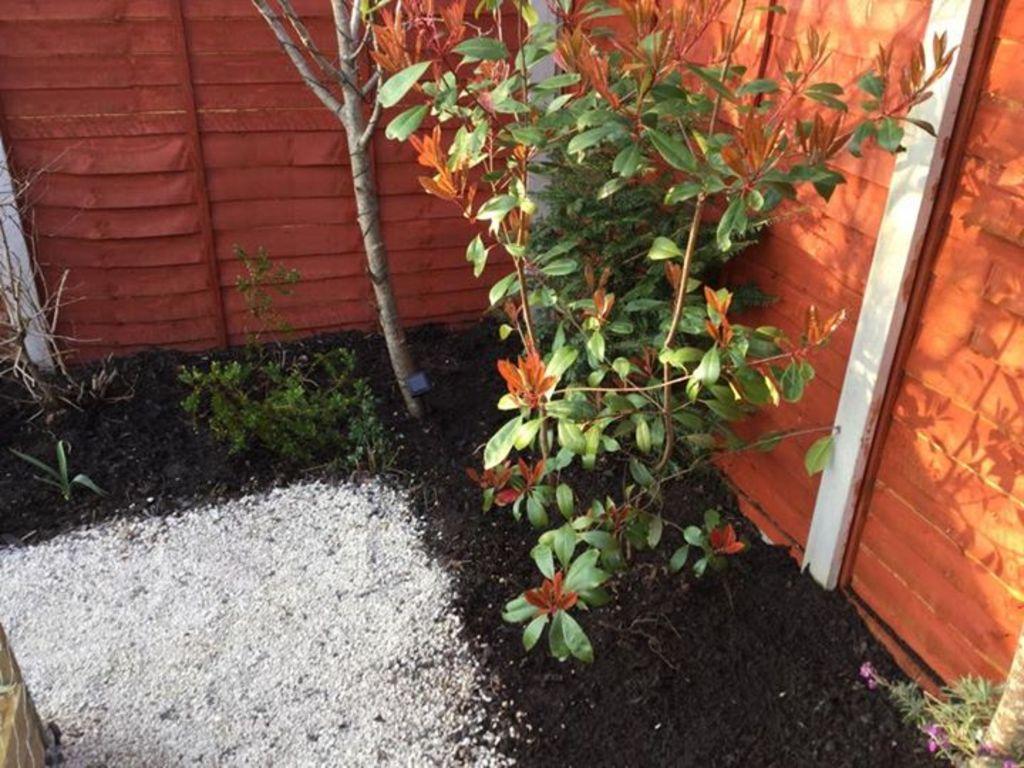How would you summarize this image in a sentence or two? In this image there are plants, a fence, mud and white color sand. 